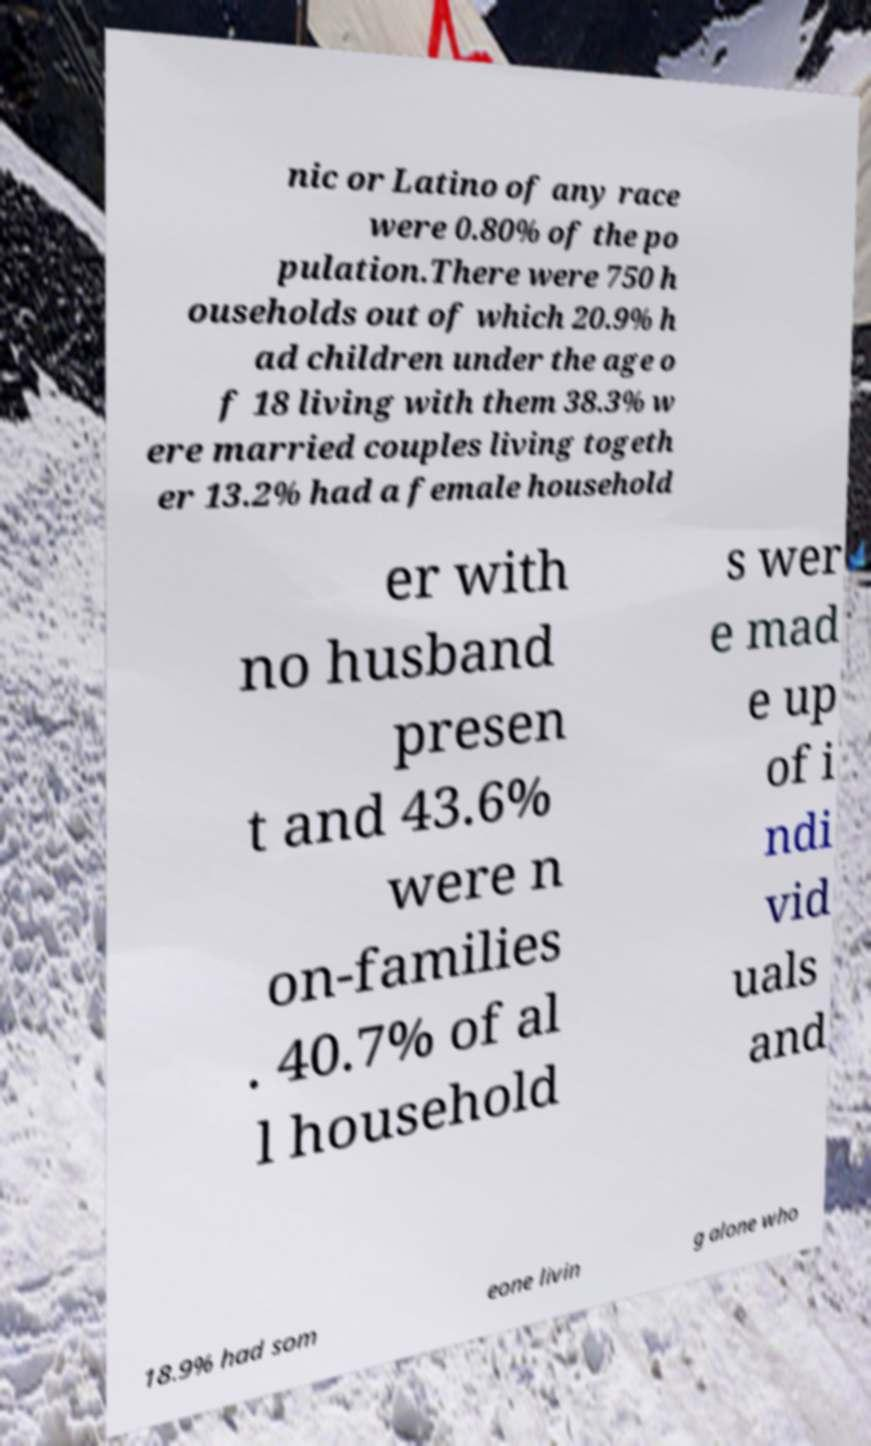Please read and relay the text visible in this image. What does it say? nic or Latino of any race were 0.80% of the po pulation.There were 750 h ouseholds out of which 20.9% h ad children under the age o f 18 living with them 38.3% w ere married couples living togeth er 13.2% had a female household er with no husband presen t and 43.6% were n on-families . 40.7% of al l household s wer e mad e up of i ndi vid uals and 18.9% had som eone livin g alone who 